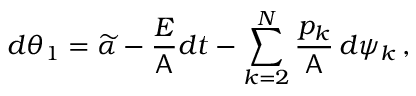Convert formula to latex. <formula><loc_0><loc_0><loc_500><loc_500>d \theta _ { 1 } = \widetilde { \alpha } - \frac { E } { A } d t - \sum _ { k = 2 } ^ { N } \frac { p _ { k } } { A } \, d \psi _ { k } \, ,</formula> 